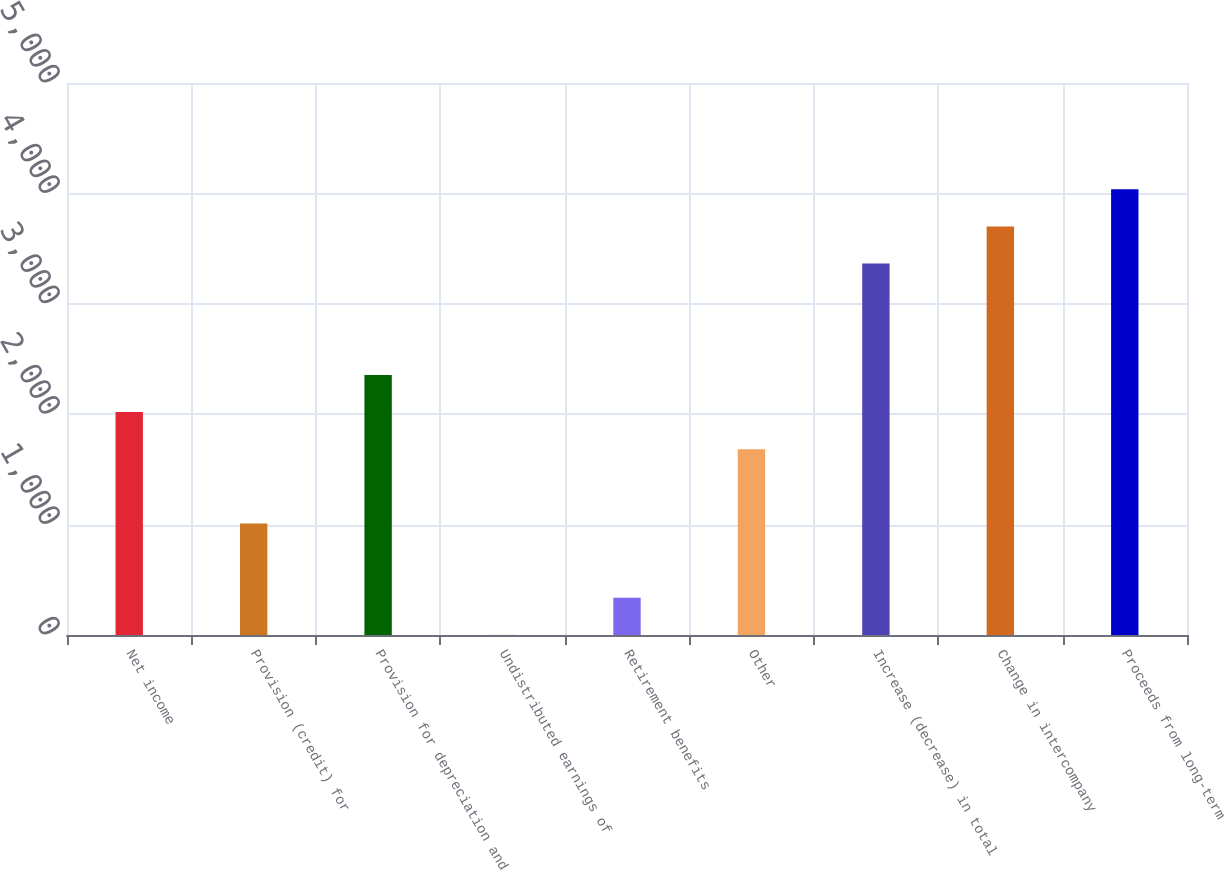Convert chart. <chart><loc_0><loc_0><loc_500><loc_500><bar_chart><fcel>Net income<fcel>Provision (credit) for<fcel>Provision for depreciation and<fcel>Undistributed earnings of<fcel>Retirement benefits<fcel>Other<fcel>Increase (decrease) in total<fcel>Change in intercompany<fcel>Proceeds from long-term<nl><fcel>2018.88<fcel>1009.89<fcel>2355.21<fcel>0.9<fcel>337.23<fcel>1682.55<fcel>3364.2<fcel>3700.53<fcel>4036.86<nl></chart> 